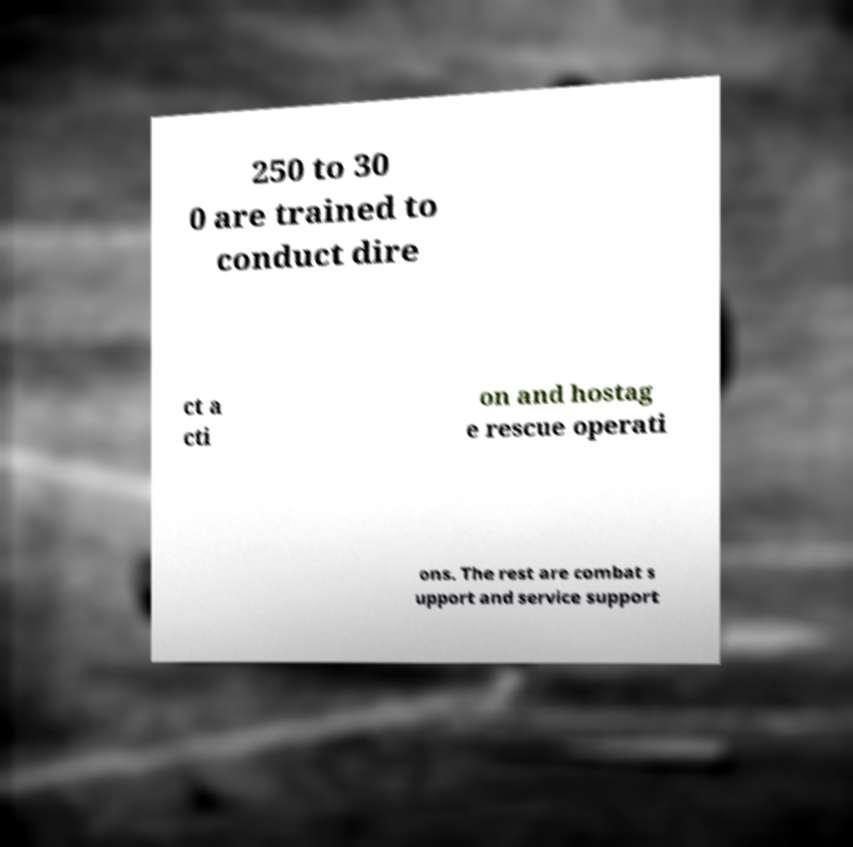Can you accurately transcribe the text from the provided image for me? 250 to 30 0 are trained to conduct dire ct a cti on and hostag e rescue operati ons. The rest are combat s upport and service support 